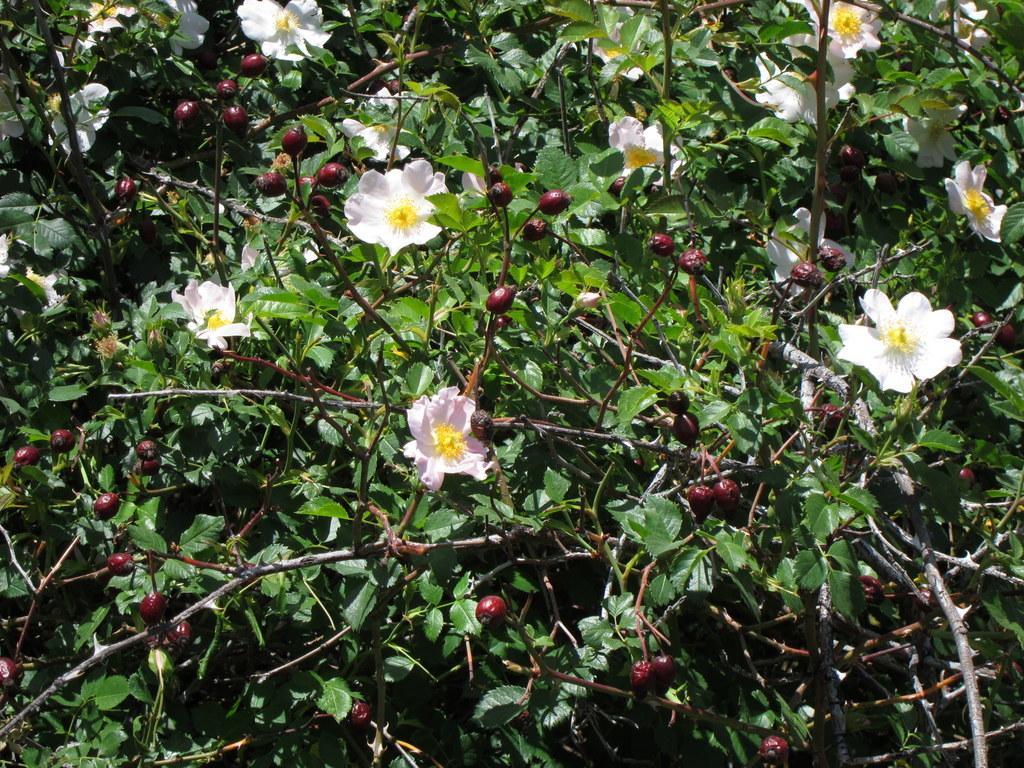In one or two sentences, can you explain what this image depicts? In the center of the image there are plants with flowers and fruits. 